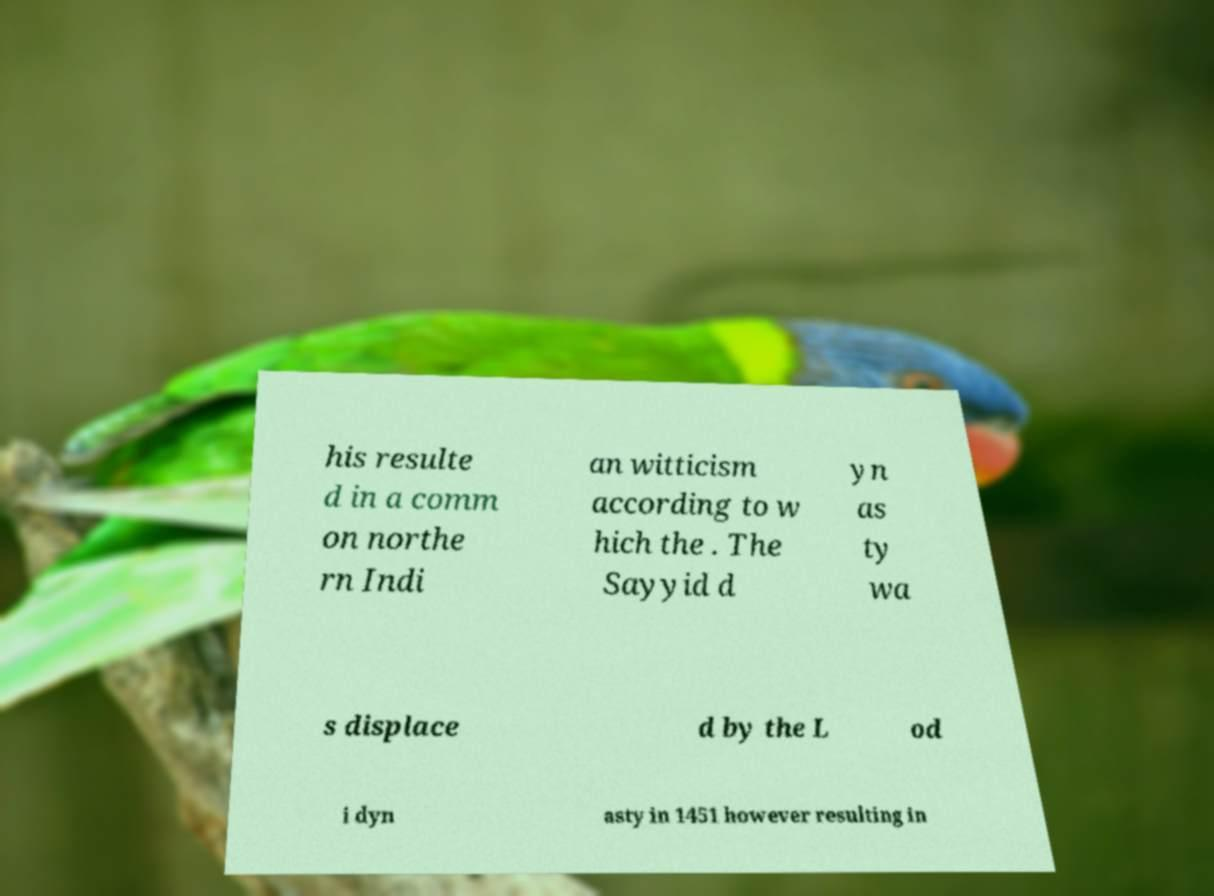Could you assist in decoding the text presented in this image and type it out clearly? his resulte d in a comm on northe rn Indi an witticism according to w hich the . The Sayyid d yn as ty wa s displace d by the L od i dyn asty in 1451 however resulting in 